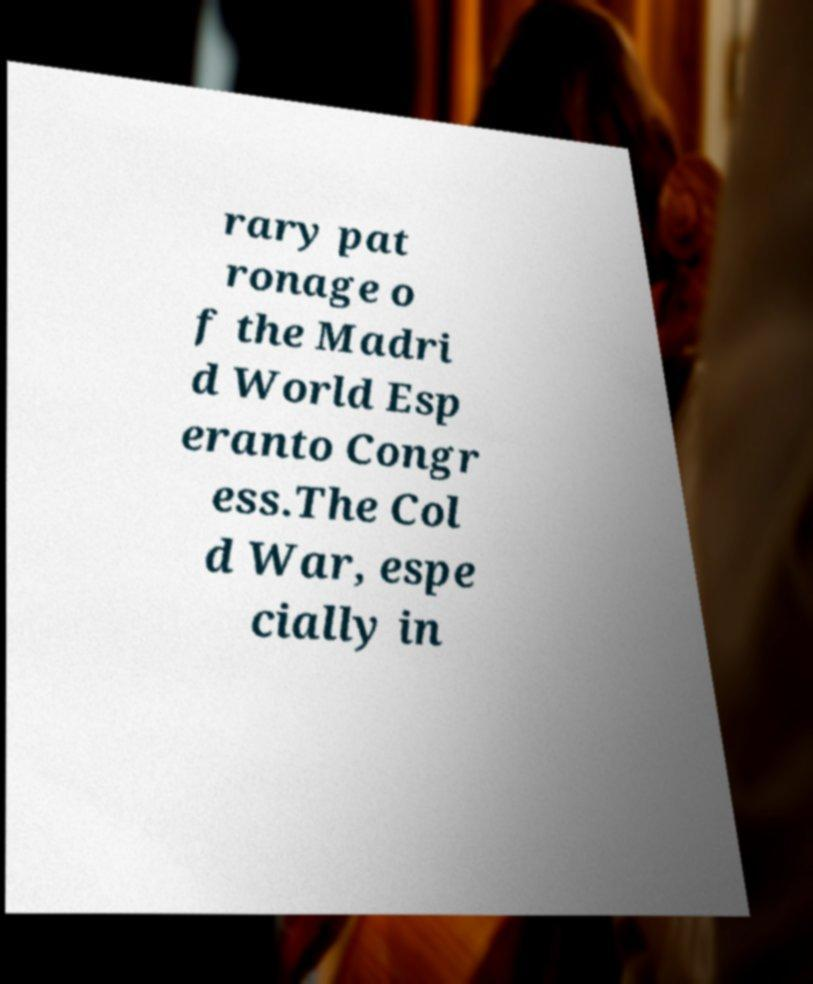Please identify and transcribe the text found in this image. rary pat ronage o f the Madri d World Esp eranto Congr ess.The Col d War, espe cially in 